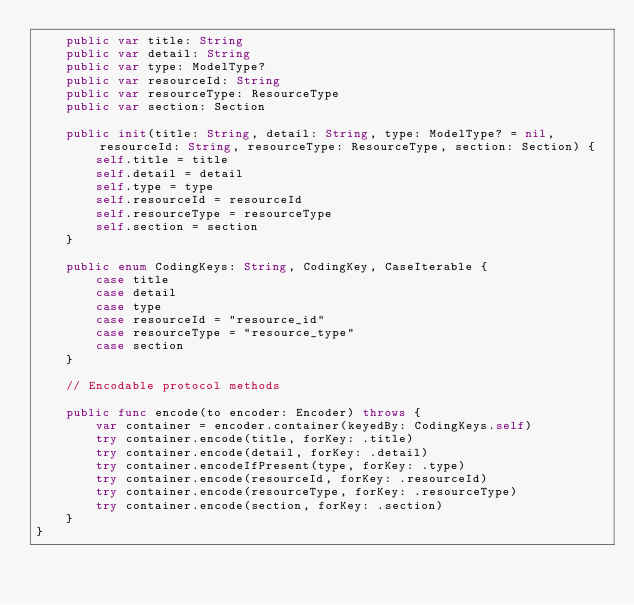Convert code to text. <code><loc_0><loc_0><loc_500><loc_500><_Swift_>    public var title: String
    public var detail: String
    public var type: ModelType?
    public var resourceId: String
    public var resourceType: ResourceType
    public var section: Section

    public init(title: String, detail: String, type: ModelType? = nil, resourceId: String, resourceType: ResourceType, section: Section) {
        self.title = title
        self.detail = detail
        self.type = type
        self.resourceId = resourceId
        self.resourceType = resourceType
        self.section = section
    }

    public enum CodingKeys: String, CodingKey, CaseIterable {
        case title
        case detail
        case type
        case resourceId = "resource_id"
        case resourceType = "resource_type"
        case section
    }

    // Encodable protocol methods

    public func encode(to encoder: Encoder) throws {
        var container = encoder.container(keyedBy: CodingKeys.self)
        try container.encode(title, forKey: .title)
        try container.encode(detail, forKey: .detail)
        try container.encodeIfPresent(type, forKey: .type)
        try container.encode(resourceId, forKey: .resourceId)
        try container.encode(resourceType, forKey: .resourceType)
        try container.encode(section, forKey: .section)
    }
}

</code> 